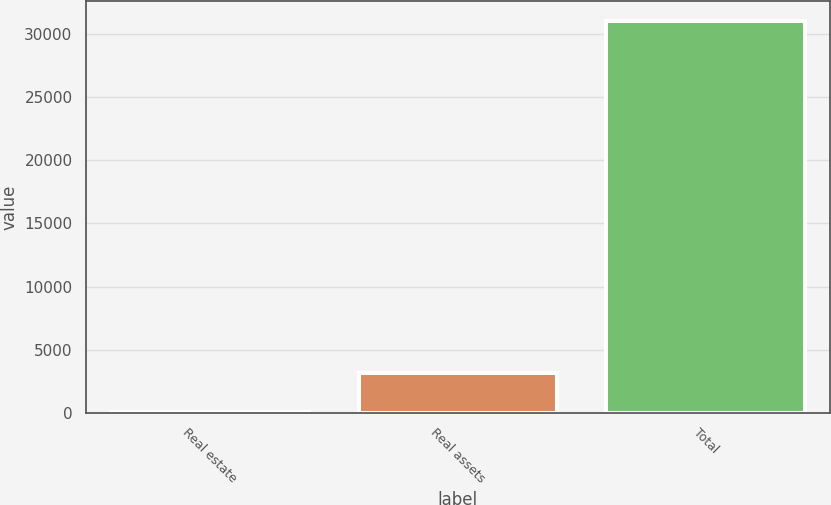<chart> <loc_0><loc_0><loc_500><loc_500><bar_chart><fcel>Real estate<fcel>Real assets<fcel>Total<nl><fcel>14<fcel>3119.7<fcel>31071<nl></chart> 